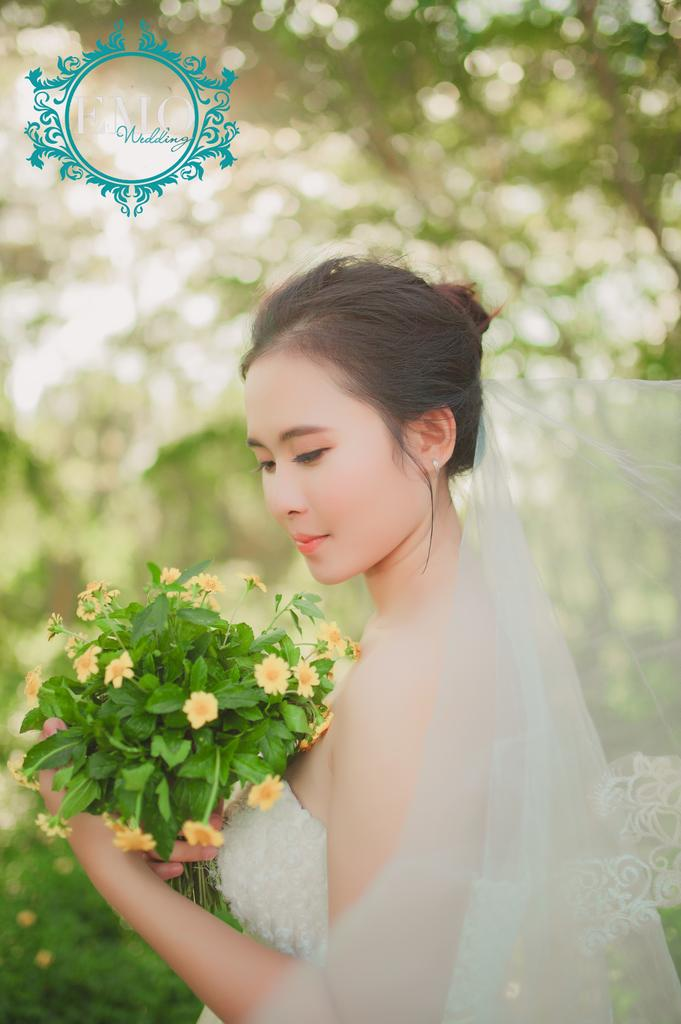Who is the main subject in the image? There is a lady in the image. What is the lady wearing on her head? The lady is wearing a veil. What is the lady holding in the image? The lady is holding a flower bouquet. Can you describe the background of the image? The background of the image is blurred. Is there any additional information or markings on the image? Yes, there is a watermark in the top left corner of the image. How many babies are visible in the image? There are no babies present in the image. Is there a chessboard in the image? There is no chessboard visible in the image. Can you see the lady's toe in the image? There is no visible toe of the lady in the image. 